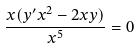<formula> <loc_0><loc_0><loc_500><loc_500>\frac { x ( y ^ { \prime } x ^ { 2 } - 2 x y ) } { x ^ { 5 } } = 0</formula> 